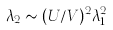<formula> <loc_0><loc_0><loc_500><loc_500>\lambda _ { 2 } \sim ( U / V ) ^ { 2 } \lambda _ { 1 } ^ { 2 }</formula> 